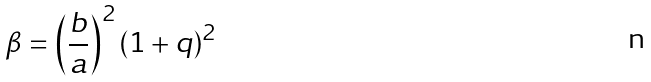Convert formula to latex. <formula><loc_0><loc_0><loc_500><loc_500>\beta = \left ( \frac { b } { a } \right ) ^ { 2 } ( 1 + q ) ^ { 2 }</formula> 